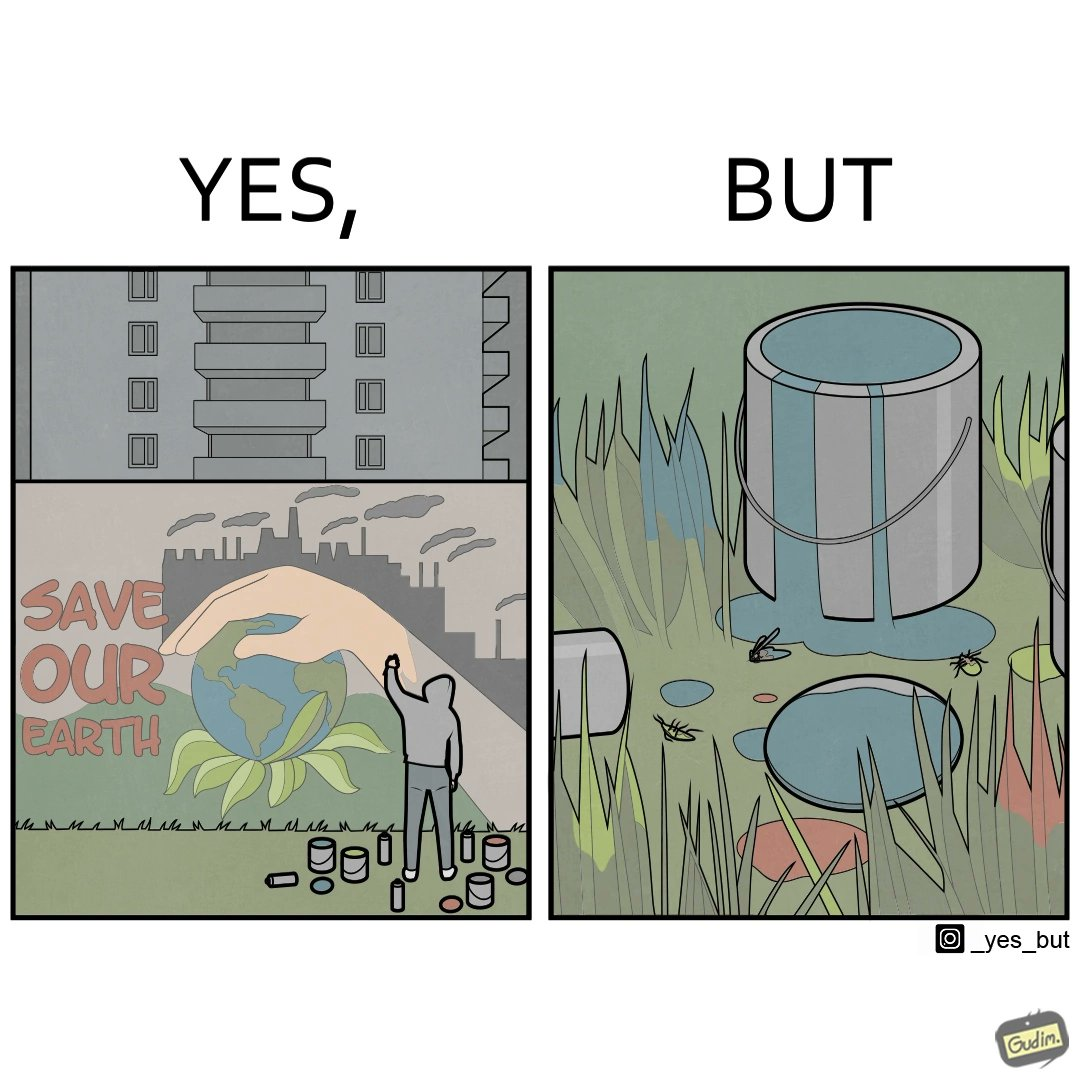Provide a description of this image. The image is ironical, as the cans of paint used to make graffiti on the theme "Save the Earth" seems to be destroying the Earth when it overflows on the grass, as it is harmful for the flora and fauna, as can be seen from the dying insects. 